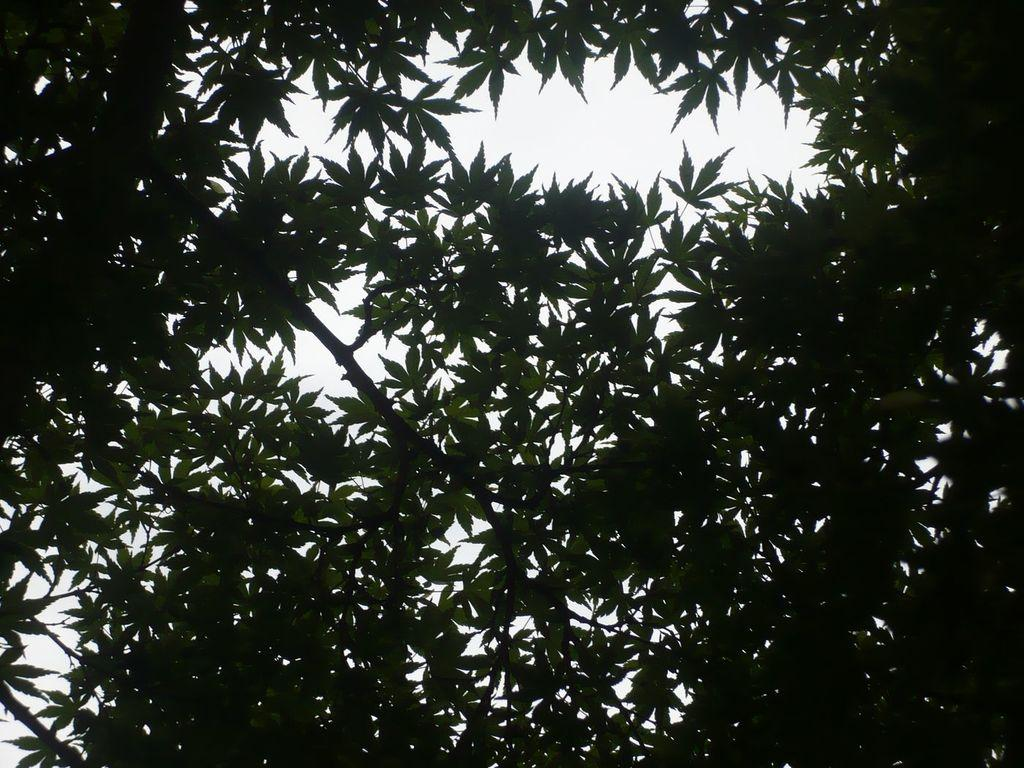What type of vegetation can be seen in the image? There are leaves and branches in the image. What is visible in the background of the image? The sky is visible in the background of the image. What type of mint can be seen growing on the branches in the image? There is no mint visible in the image; only leaves and branches are present. 